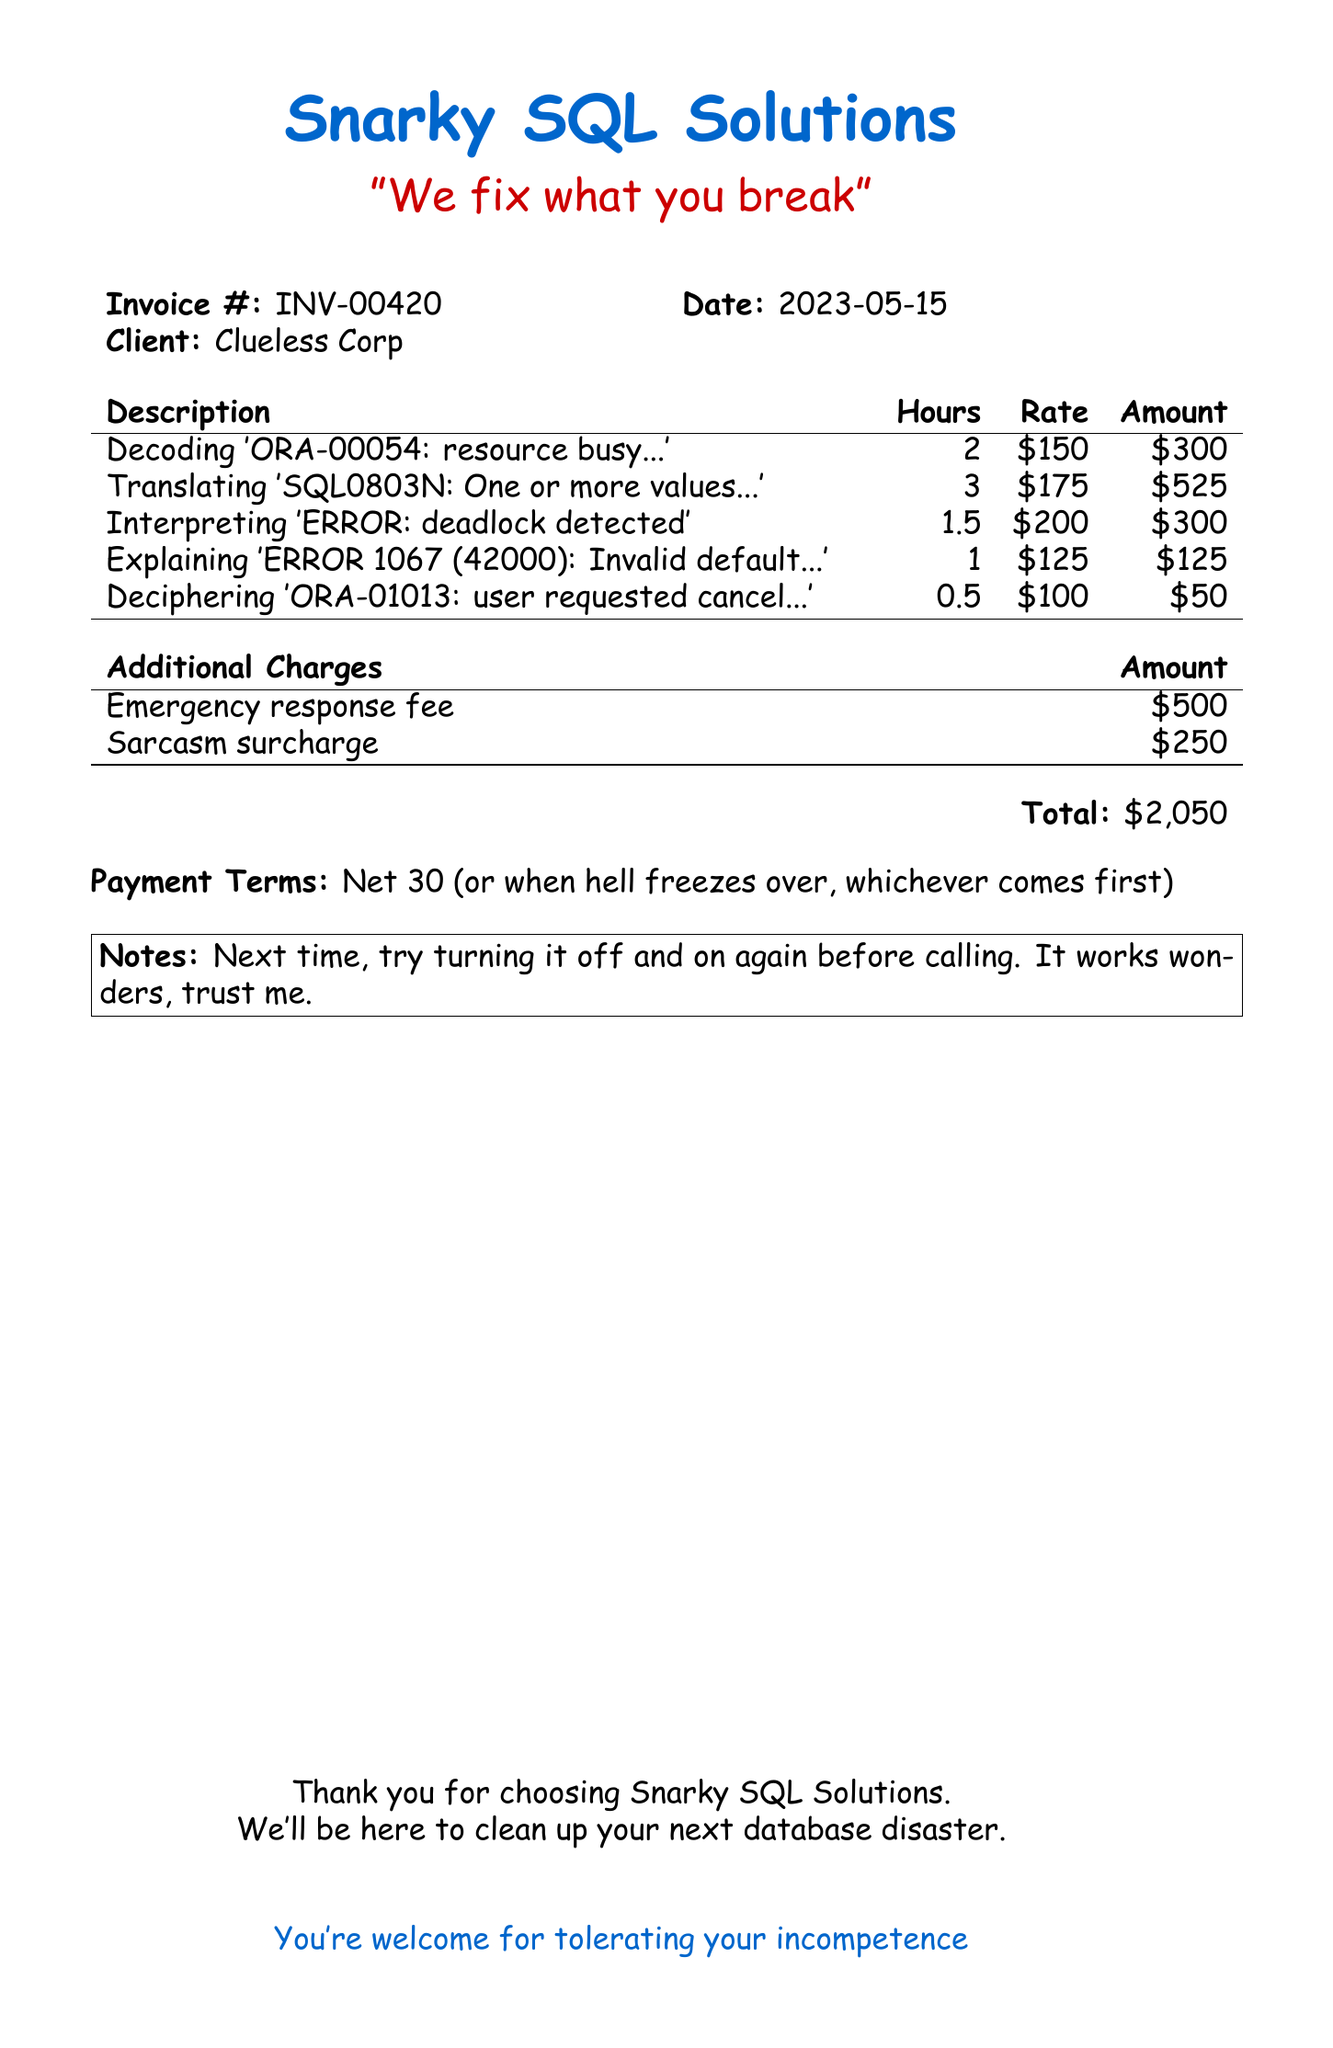What is the company name? The company name is stated at the top of the document.
Answer: Snarky SQL Solutions What is the invoice number? The invoice number is indicated in a specific format on the document.
Answer: INV-00420 What is the total amount billed? The total amount billed is calculated from the line items and additional charges.
Answer: $2,050 How many hours were spent on interpreting deadlock errors? The hours for this specific task are listed in the line items section.
Answer: 1.5 What is the rate for decoding the 'ORA-00054' error? The rate for this service is provided alongside the description in the document.
Answer: $150 What does the sarcasm surcharge amount to? The sarcasm surcharge is listed in the additional charges section of the invoice.
Answer: $250 What is the payment term? The payment term is specified towards the end of the document.
Answer: Net 30 What is the description for the emergency response fee? The emergency response fee has a unique description noted in the additional charges.
Answer: Drop everything because your production database is on fire Who is the client? The client name is found next to the invoice details in the document.
Answer: Clueless Corp 